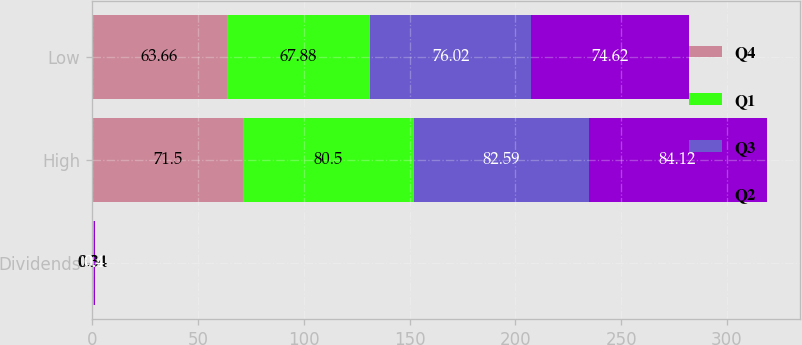<chart> <loc_0><loc_0><loc_500><loc_500><stacked_bar_chart><ecel><fcel>Dividends<fcel>High<fcel>Low<nl><fcel>Q4<fcel>0.34<fcel>71.5<fcel>63.66<nl><fcel>Q1<fcel>0.34<fcel>80.5<fcel>67.88<nl><fcel>Q3<fcel>0.4<fcel>82.59<fcel>76.02<nl><fcel>Q2<fcel>0.4<fcel>84.12<fcel>74.62<nl></chart> 